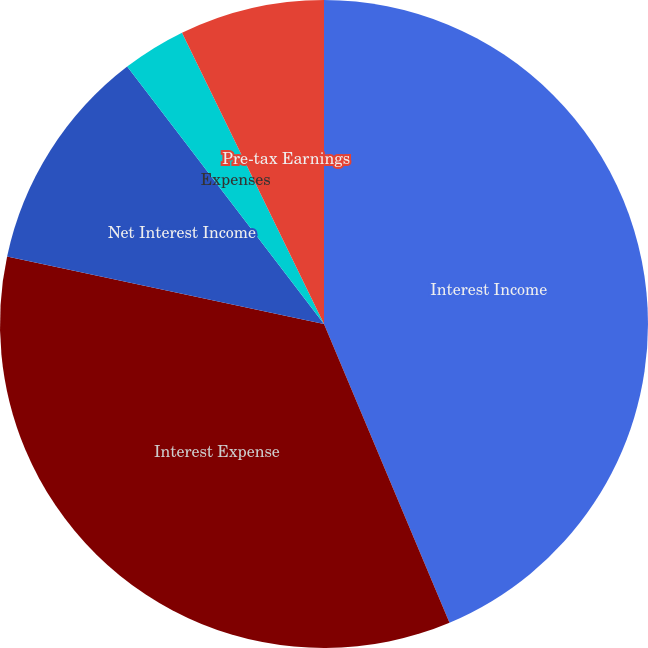Convert chart. <chart><loc_0><loc_0><loc_500><loc_500><pie_chart><fcel>Interest Income<fcel>Interest Expense<fcel>Net Interest Income<fcel>Expenses<fcel>Pre-tax Earnings<nl><fcel>43.67%<fcel>34.67%<fcel>11.27%<fcel>3.17%<fcel>7.22%<nl></chart> 